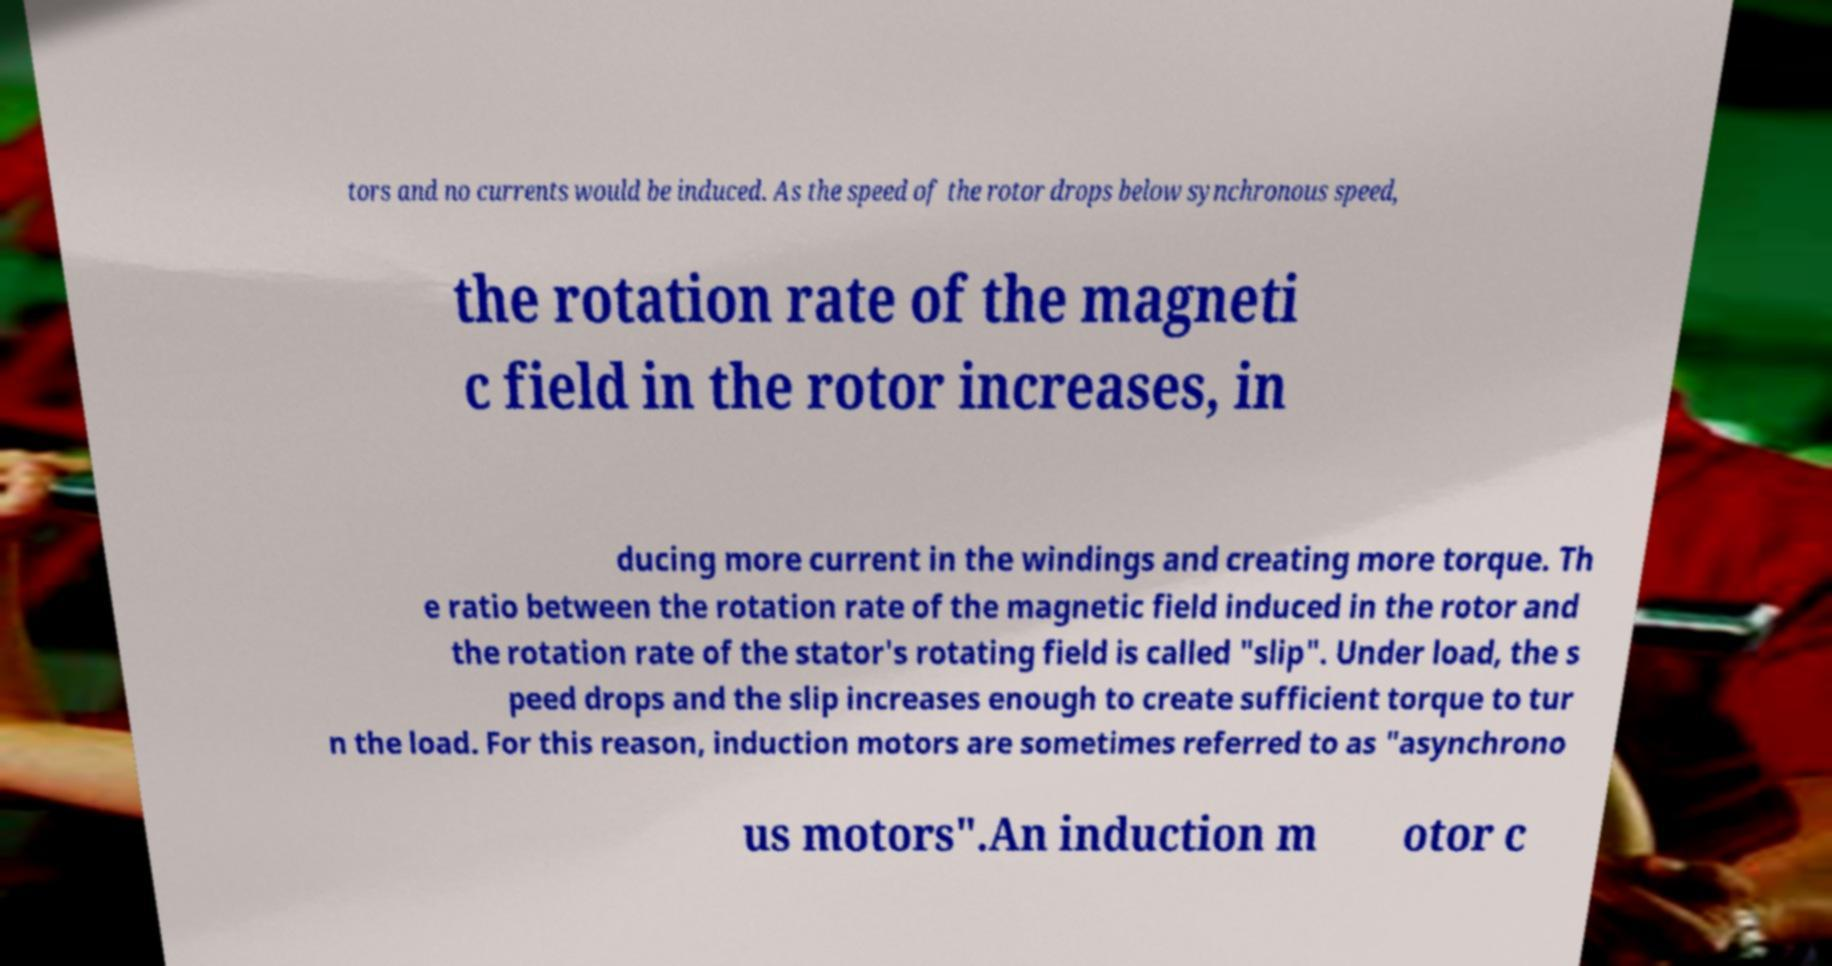Can you read and provide the text displayed in the image?This photo seems to have some interesting text. Can you extract and type it out for me? tors and no currents would be induced. As the speed of the rotor drops below synchronous speed, the rotation rate of the magneti c field in the rotor increases, in ducing more current in the windings and creating more torque. Th e ratio between the rotation rate of the magnetic field induced in the rotor and the rotation rate of the stator's rotating field is called "slip". Under load, the s peed drops and the slip increases enough to create sufficient torque to tur n the load. For this reason, induction motors are sometimes referred to as "asynchrono us motors".An induction m otor c 